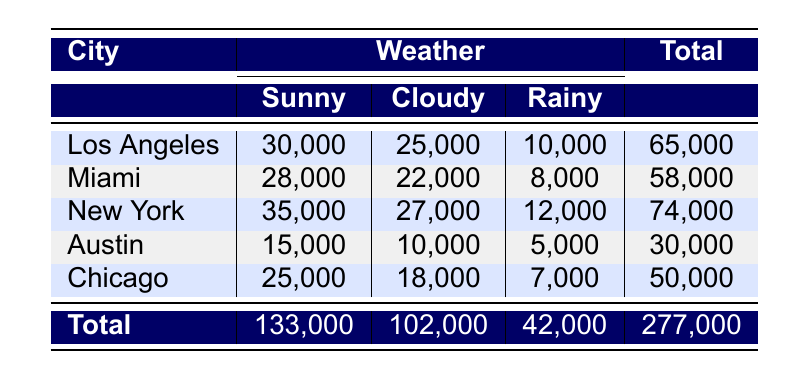What is the total attendance for racing events in Los Angeles? The total attendance for Los Angeles is given in the last column of the table, which shows 65,000.
Answer: 65,000 Which city had the highest attendance on rainy days? To find the highest attendance in rainy weather, we look at the "Rainy" column. The values are 10,000 (Los Angeles), 8,000 (Miami), 12,000 (New York), 5,000 (Austin), and 7,000 (Chicago). The highest is 12,000 from New York.
Answer: New York Is the total attendance for Miami events greater than that for Austin events? The total attendance for Miami is 58,000 while for Austin it is 30,000. Since 58,000 is greater than 30,000, the answer is yes.
Answer: Yes What is the average attendance for racing events in Chicago? To find the average attendance for Chicago, we sum the attendances: 25,000 (Sunny) + 18,000 (Cloudy) + 7,000 (Rainy) = 50,000. Then we divide by the number of categories (3): 50,000 / 3 = 16,667.
Answer: 16,667 Which weather type had the lowest total attendance, and what was that total? We sum the total attendances for each weather condition: Sunny: 133,000, Cloudy: 102,000, Rainy: 42,000. The lowest is 42,000 for rainy weather.
Answer: Rainy, 42,000 How many more attendees did New York have on sunny days than Miami? For sunny days, New York attendance is 35,000 and Miami is 28,000. To find the difference, we subtract 28,000 from 35,000, which equals 7,000.
Answer: 7,000 Do Austin events consistently attract a higher attendance on sunny days compared to Chicago? Looking at the table, the attendance for Austin on sunny days is 15,000 while for Chicago it is 25,000. Since 15,000 is less than 25,000, the answer is no.
Answer: No What is the total attendance across all cities for cloudy weather? The total attendance for cloudy weather is calculated by adding the values in the "Cloudy" column: 25,000 (Los Angeles) + 22,000 (Miami) + 27,000 (New York) + 10,000 (Austin) + 18,000 (Chicago) = 102,000.
Answer: 102,000 Which city had the lowest attendance overall? By comparing the totals for each city, we see that Austin has a total attendance of 30,000, which is the lowest compared to Los Angeles (65,000), Miami (58,000), New York (74,000), and Chicago (50,000).
Answer: Austin 